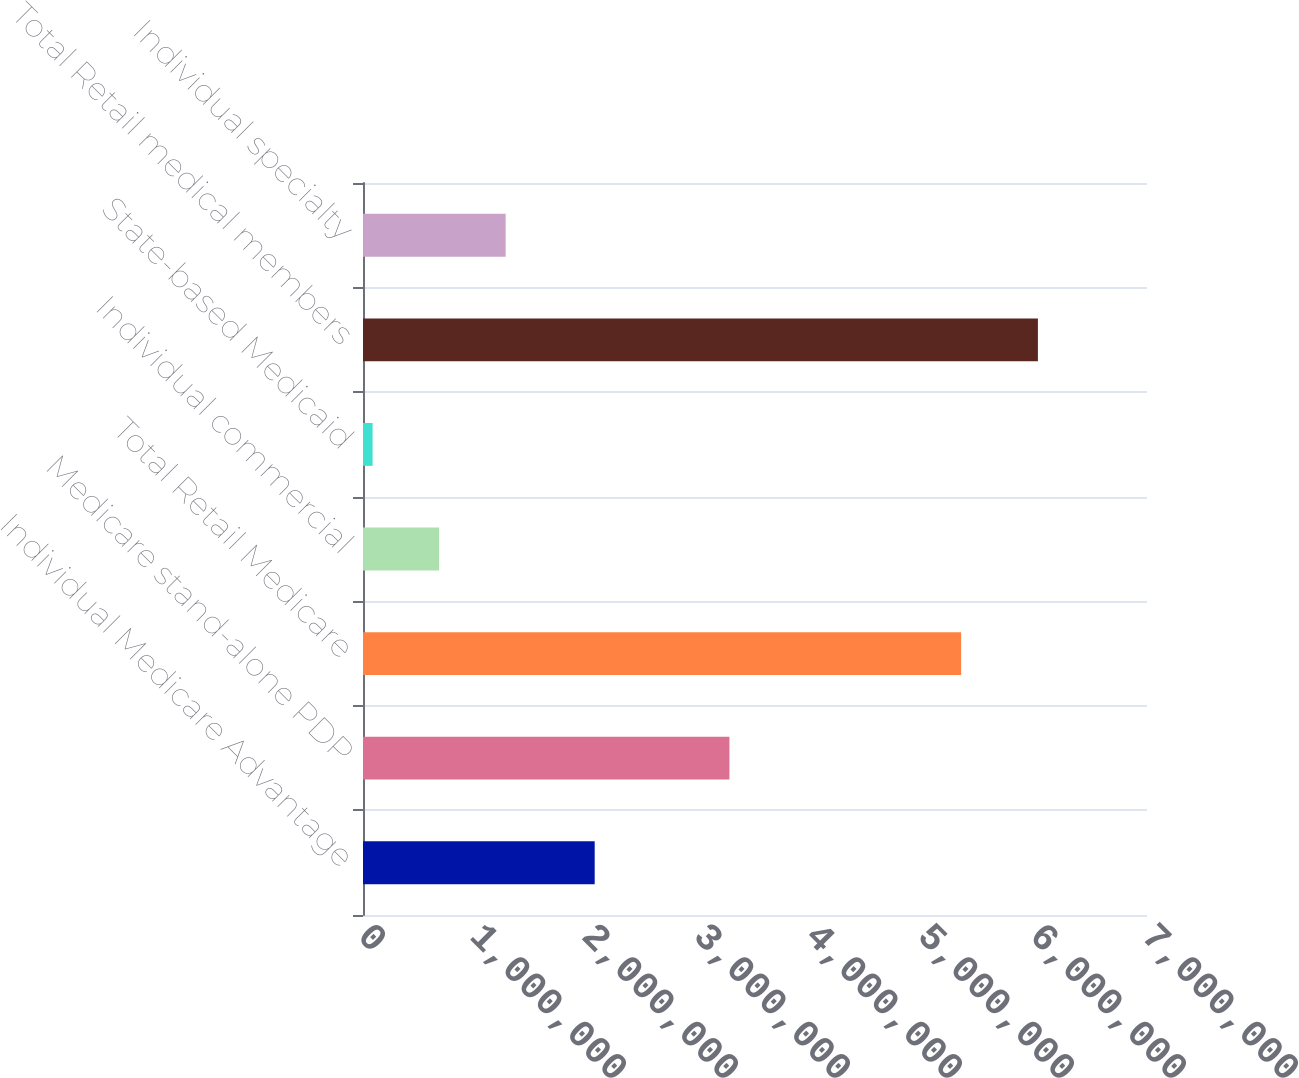<chart> <loc_0><loc_0><loc_500><loc_500><bar_chart><fcel>Individual Medicare Advantage<fcel>Medicare stand-alone PDP<fcel>Total Retail Medicare<fcel>Individual commercial<fcel>State-based Medicaid<fcel>Total Retail medical members<fcel>Individual specialty<nl><fcel>2.0687e+06<fcel>3.2717e+06<fcel>5.3404e+06<fcel>679550<fcel>85500<fcel>6.026e+06<fcel>1.2736e+06<nl></chart> 